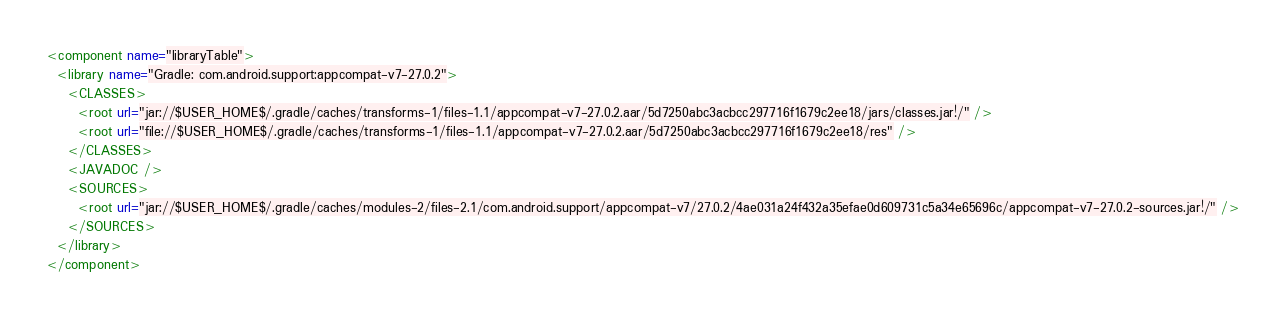<code> <loc_0><loc_0><loc_500><loc_500><_XML_><component name="libraryTable">
  <library name="Gradle: com.android.support:appcompat-v7-27.0.2">
    <CLASSES>
      <root url="jar://$USER_HOME$/.gradle/caches/transforms-1/files-1.1/appcompat-v7-27.0.2.aar/5d7250abc3acbcc297716f1679c2ee18/jars/classes.jar!/" />
      <root url="file://$USER_HOME$/.gradle/caches/transforms-1/files-1.1/appcompat-v7-27.0.2.aar/5d7250abc3acbcc297716f1679c2ee18/res" />
    </CLASSES>
    <JAVADOC />
    <SOURCES>
      <root url="jar://$USER_HOME$/.gradle/caches/modules-2/files-2.1/com.android.support/appcompat-v7/27.0.2/4ae031a24f432a35efae0d609731c5a34e65696c/appcompat-v7-27.0.2-sources.jar!/" />
    </SOURCES>
  </library>
</component></code> 